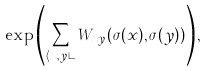Convert formula to latex. <formula><loc_0><loc_0><loc_500><loc_500>\exp \left ( \sum _ { \langle x , y \rangle } W _ { x y } ( \sigma ( x ) , \sigma ( y ) ) \right ) ,</formula> 